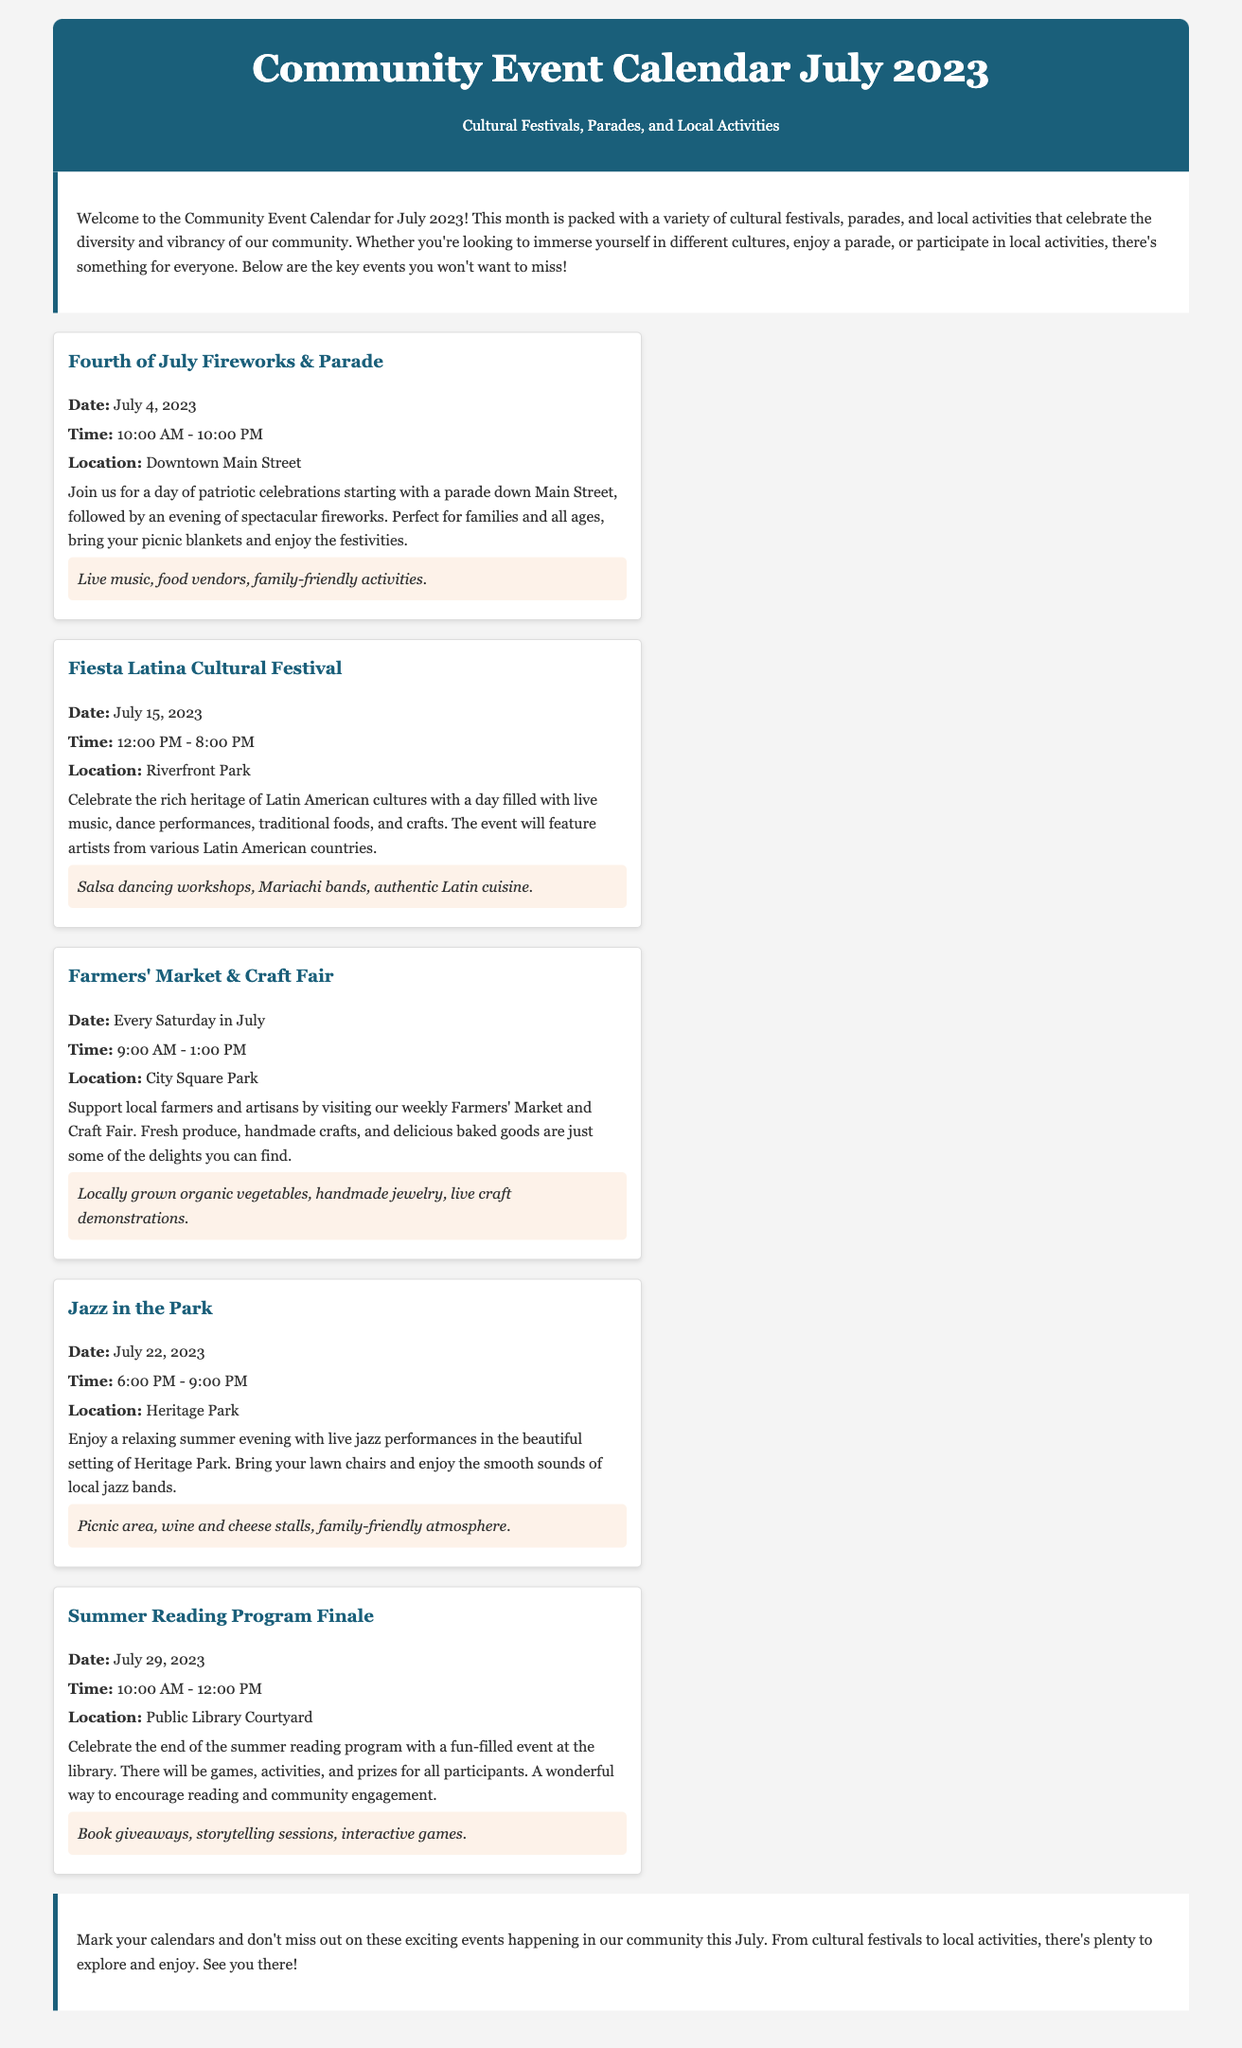What is the date of the Fourth of July Fireworks & Parade? The date is explicitly mentioned in the event details for the Fourth of July Fireworks & Parade.
Answer: July 4, 2023 What time does the Fiesta Latina Cultural Festival start? The starting time is provided in the event details for the Fiesta Latina Cultural Festival.
Answer: 12:00 PM Where is the Farmers' Market & Craft Fair held? The location is stated in the event details for the Farmers' Market & Craft Fair.
Answer: City Square Park What day of the week does the Farmers' Market occur? The frequency of the Farmers' Market is mentioned in its event details, indicating it happens weekly.
Answer: Every Saturday What type of music will be featured at Jazz in the Park? The document specifies the genre of music that will be performed during the Jazz in the Park event.
Answer: Jazz How many hours does the Summer Reading Program Finale last? The document indicates the time range for the Summer Reading Program Finale, allowing calculation of the duration.
Answer: 2 hours What is a unique activity at the Fiesta Latina Cultural Festival? The event details highlight specific activities that distinguish the Fiesta Latina Cultural Festival from other events.
Answer: Salsa dancing workshops Which event features live craft demonstrations? The event details mention the type of demonstrations that will occur, uniquely identifying the corresponding event.
Answer: Farmers' Market & Craft Fair What is the focus of the Community Event Calendar for July 2023? The introduction summarizes the overarching theme and purpose of the events listed in the calendar.
Answer: Cultural Festivals, Parades, and Local Activities 